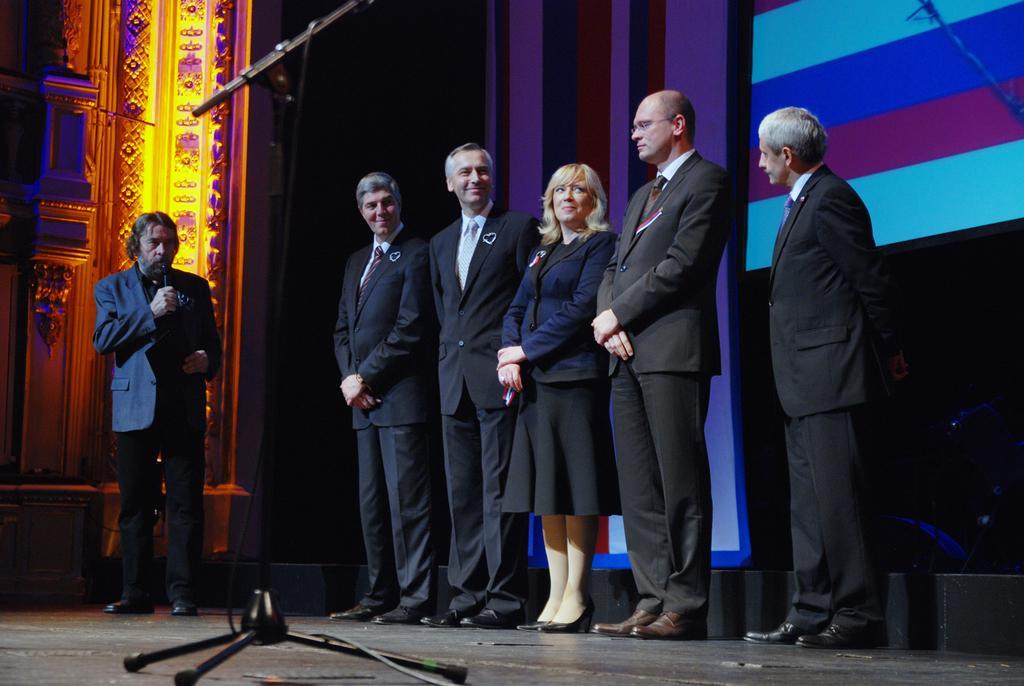Could you give a brief overview of what you see in this image? In this image we can see a few people, one of them is holding and talking, behind them there is cloth, also we can see a mic stand and a pillar. 